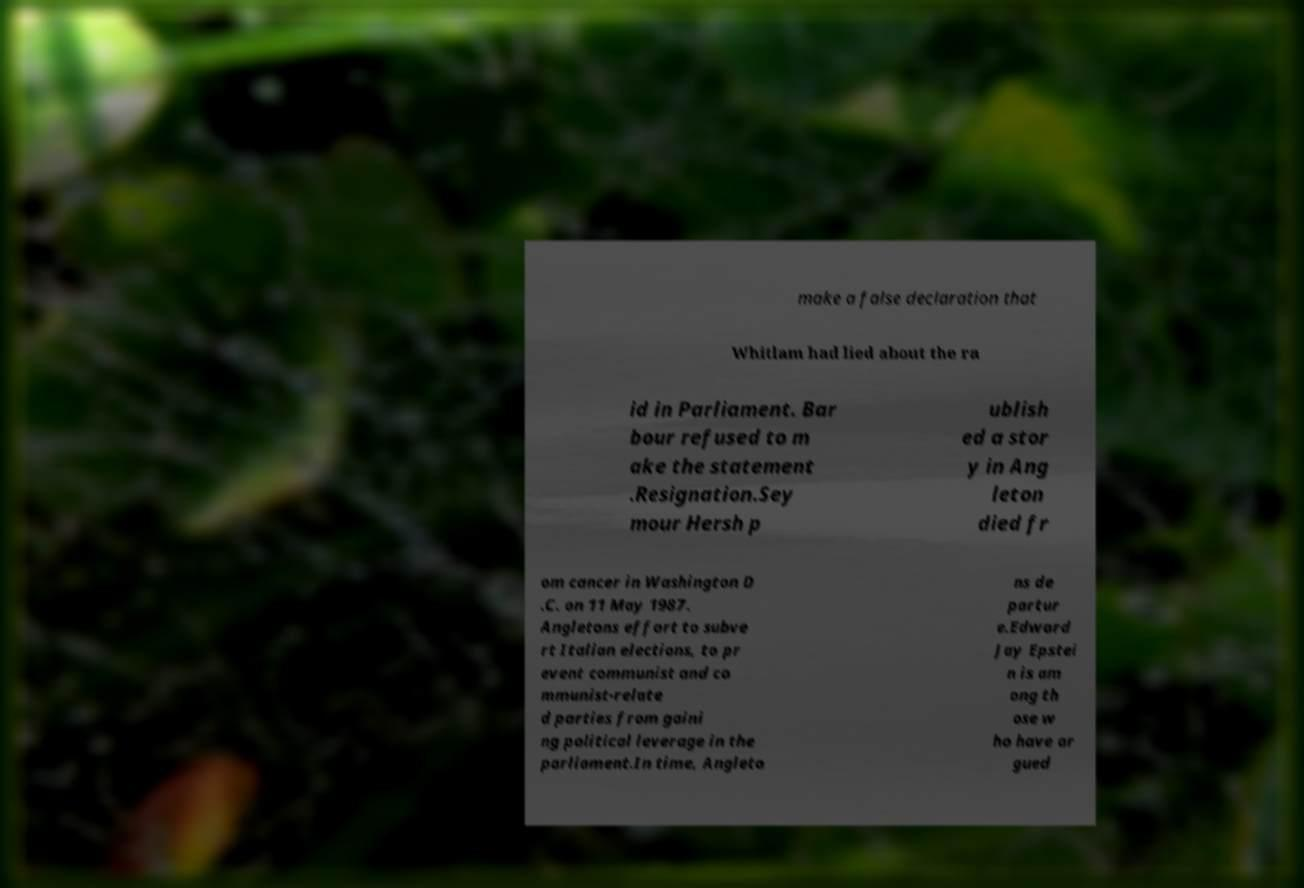What messages or text are displayed in this image? I need them in a readable, typed format. make a false declaration that Whitlam had lied about the ra id in Parliament. Bar bour refused to m ake the statement .Resignation.Sey mour Hersh p ublish ed a stor y in Ang leton died fr om cancer in Washington D .C. on 11 May 1987. Angletons effort to subve rt Italian elections, to pr event communist and co mmunist-relate d parties from gaini ng political leverage in the parliament.In time, Angleto ns de partur e.Edward Jay Epstei n is am ong th ose w ho have ar gued 